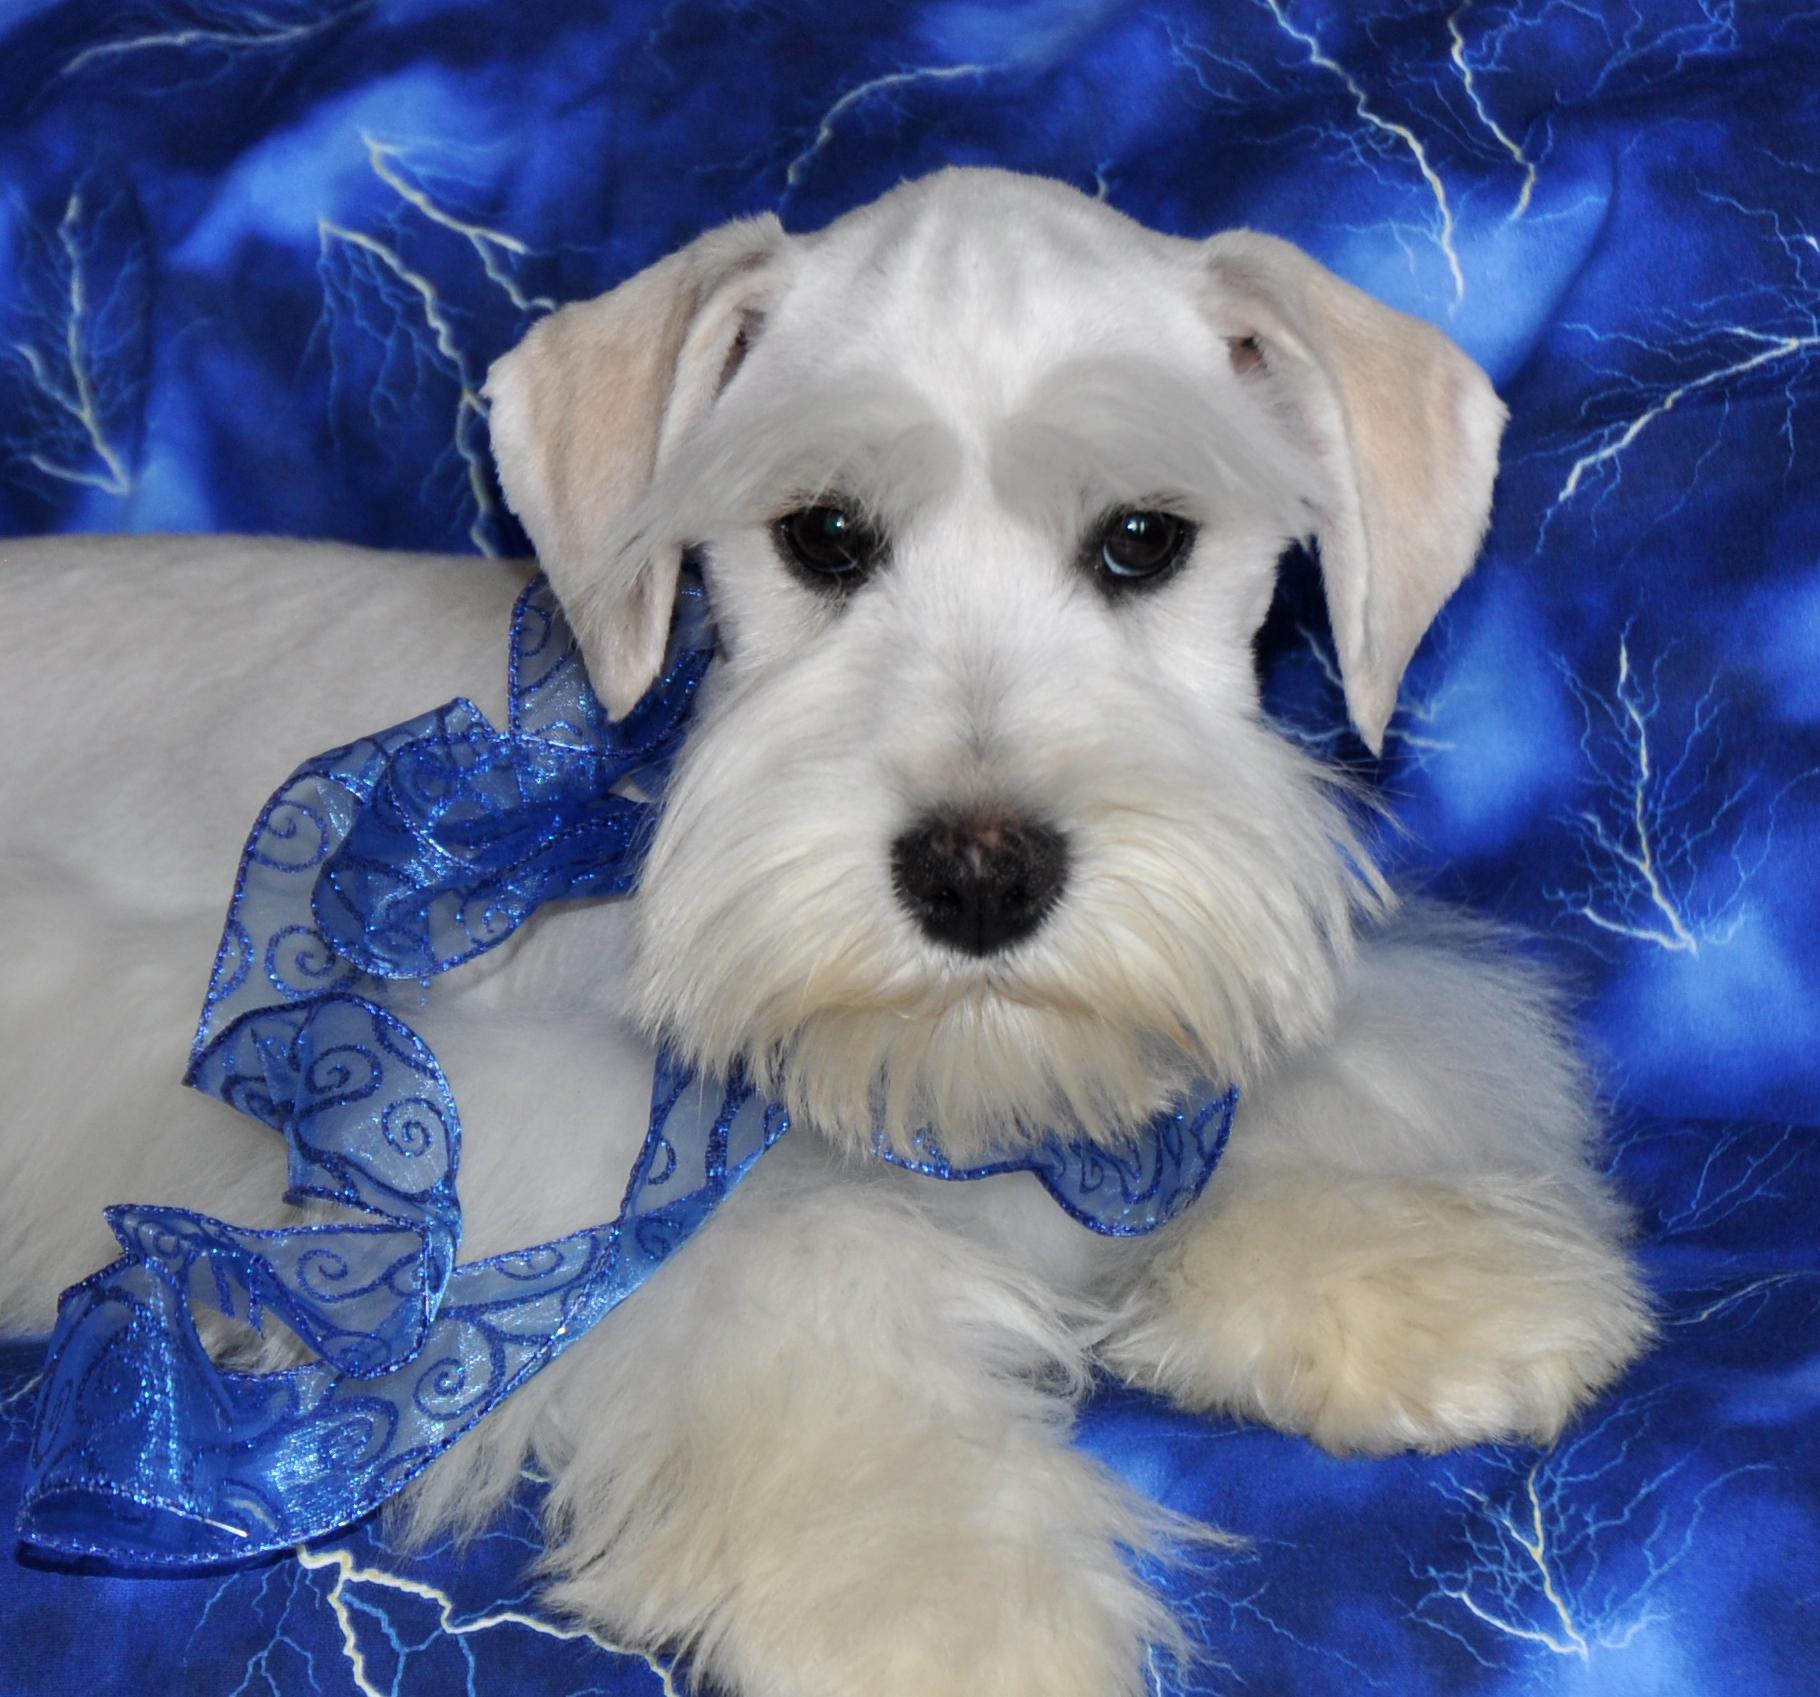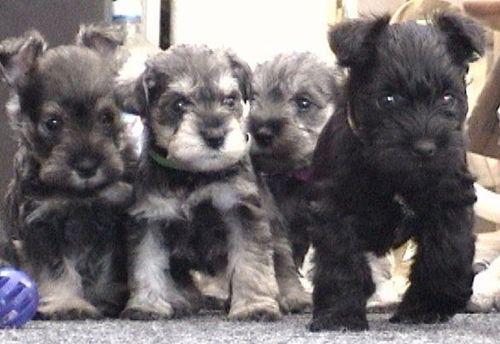The first image is the image on the left, the second image is the image on the right. Considering the images on both sides, is "At least four dogs are visible." valid? Answer yes or no. Yes. 